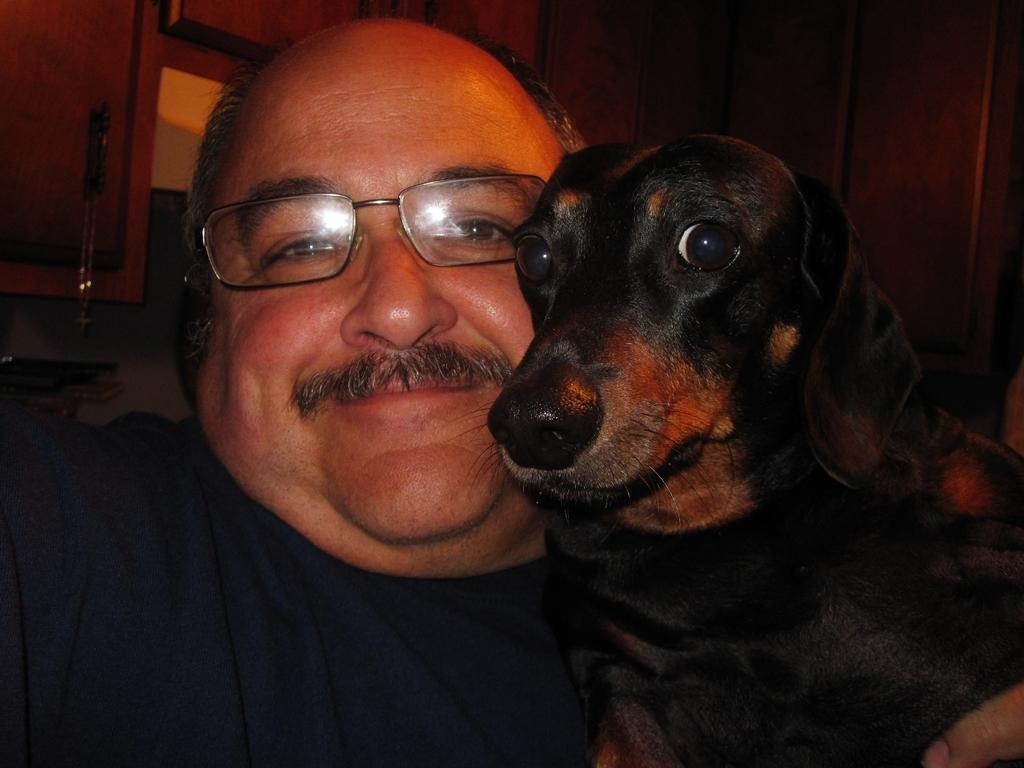Who is present in the image? There is a man in the image. What is the man doing in the image? The man is smiling in the image. What is the man wearing in the image? The man is wearing a T-shirt and spectacles in the image. What other living creature is present in the image? There is a dog in the image. What is the color of the dog in the image? The dog is black in color. What can be seen in the background of the image? There is a wooden board in the background of the image. Can you hear the beetle crawling on the wooden board in the image? There is no beetle present in the image, so it is not possible to hear it crawling on the wooden board. 